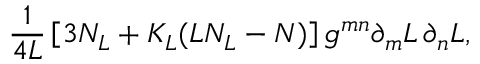<formula> <loc_0><loc_0><loc_500><loc_500>\frac { 1 } { 4 L } \left [ 3 N _ { L } + K _ { L } ( L N _ { L } - N ) \right ] g ^ { m n } \partial _ { m } L \, \partial _ { n } L ,</formula> 